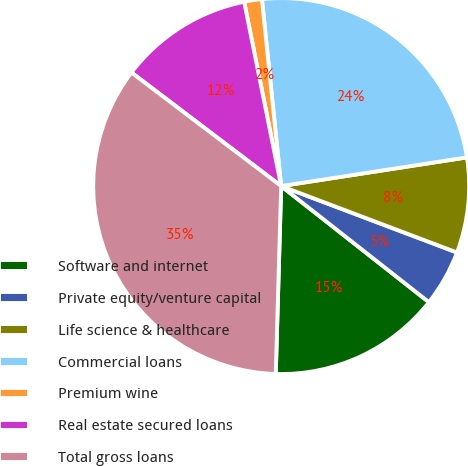Convert chart. <chart><loc_0><loc_0><loc_500><loc_500><pie_chart><fcel>Software and internet<fcel>Private equity/venture capital<fcel>Life science & healthcare<fcel>Commercial loans<fcel>Premium wine<fcel>Real estate secured loans<fcel>Total gross loans<nl><fcel>14.86%<fcel>4.85%<fcel>8.19%<fcel>24.2%<fcel>1.52%<fcel>11.52%<fcel>34.87%<nl></chart> 